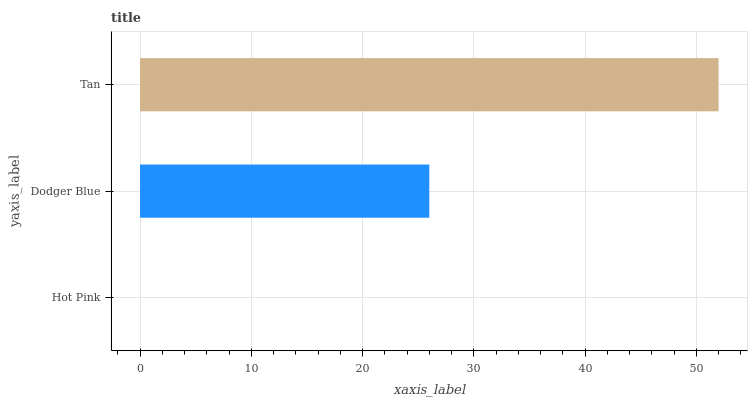Is Hot Pink the minimum?
Answer yes or no. Yes. Is Tan the maximum?
Answer yes or no. Yes. Is Dodger Blue the minimum?
Answer yes or no. No. Is Dodger Blue the maximum?
Answer yes or no. No. Is Dodger Blue greater than Hot Pink?
Answer yes or no. Yes. Is Hot Pink less than Dodger Blue?
Answer yes or no. Yes. Is Hot Pink greater than Dodger Blue?
Answer yes or no. No. Is Dodger Blue less than Hot Pink?
Answer yes or no. No. Is Dodger Blue the high median?
Answer yes or no. Yes. Is Dodger Blue the low median?
Answer yes or no. Yes. Is Hot Pink the high median?
Answer yes or no. No. Is Hot Pink the low median?
Answer yes or no. No. 